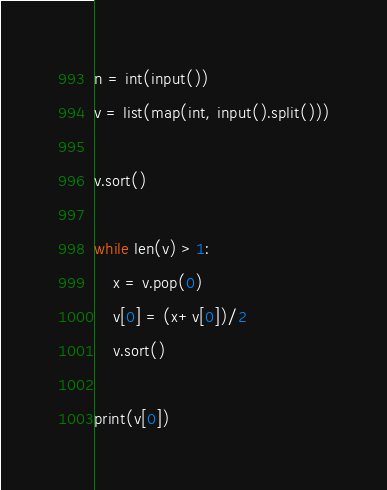Convert code to text. <code><loc_0><loc_0><loc_500><loc_500><_Python_>n = int(input())
v = list(map(int, input().split()))

v.sort()

while len(v) > 1:
    x = v.pop(0)
    v[0] = (x+v[0])/2
    v.sort()

print(v[0])
</code> 